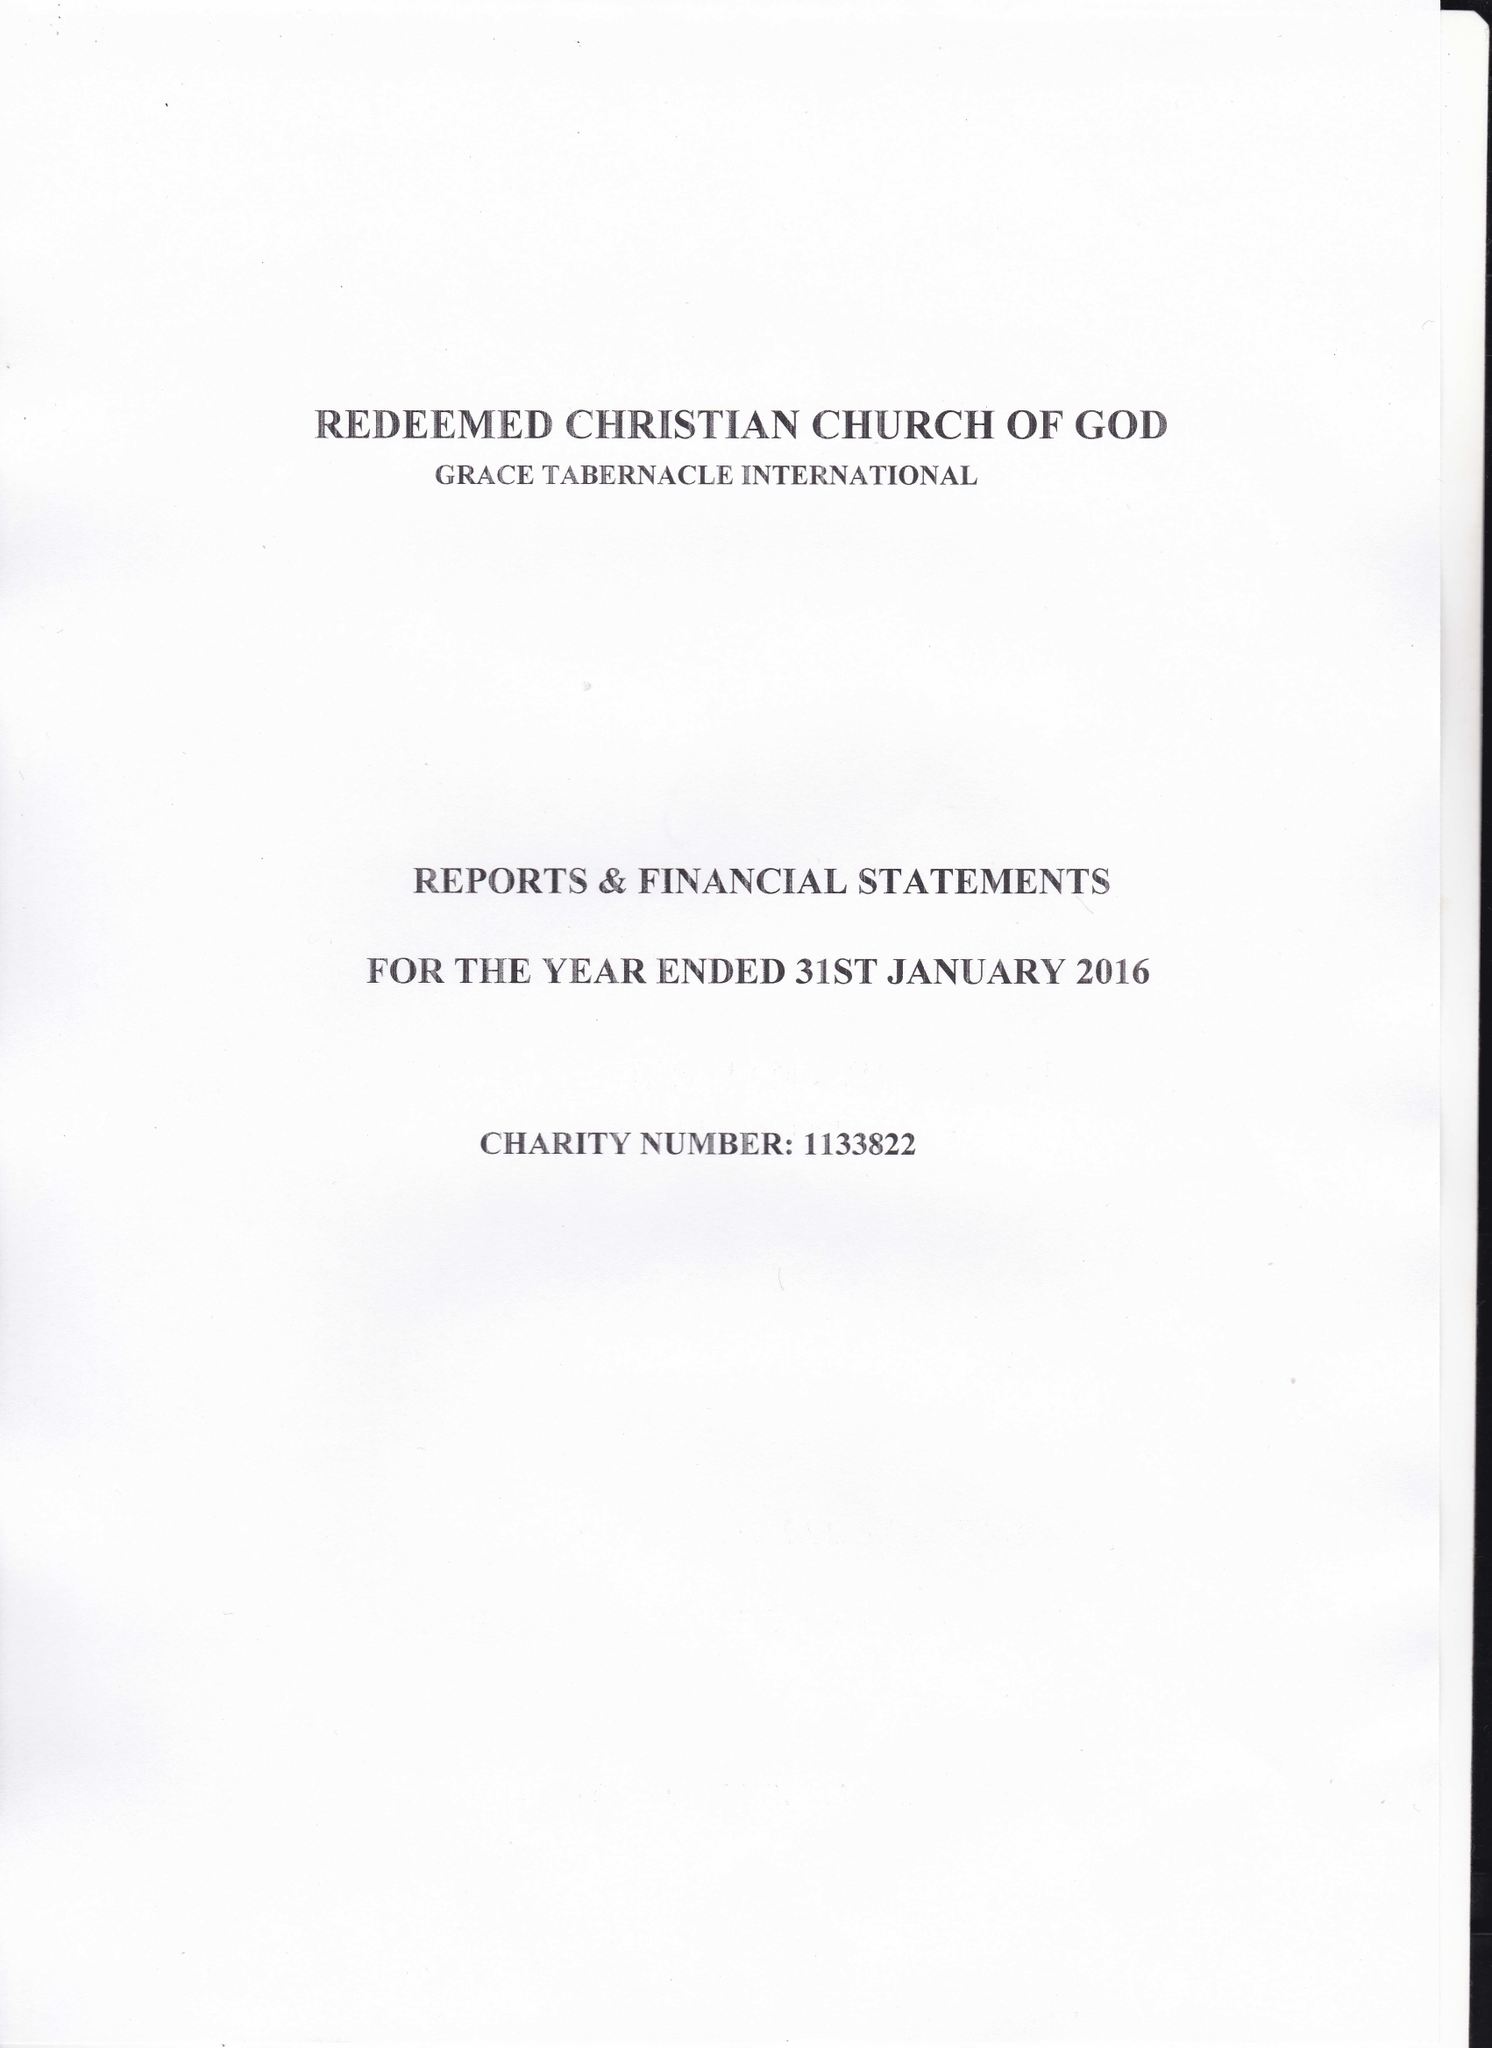What is the value for the address__street_line?
Answer the question using a single word or phrase. 616 MITCHAM ROAD 